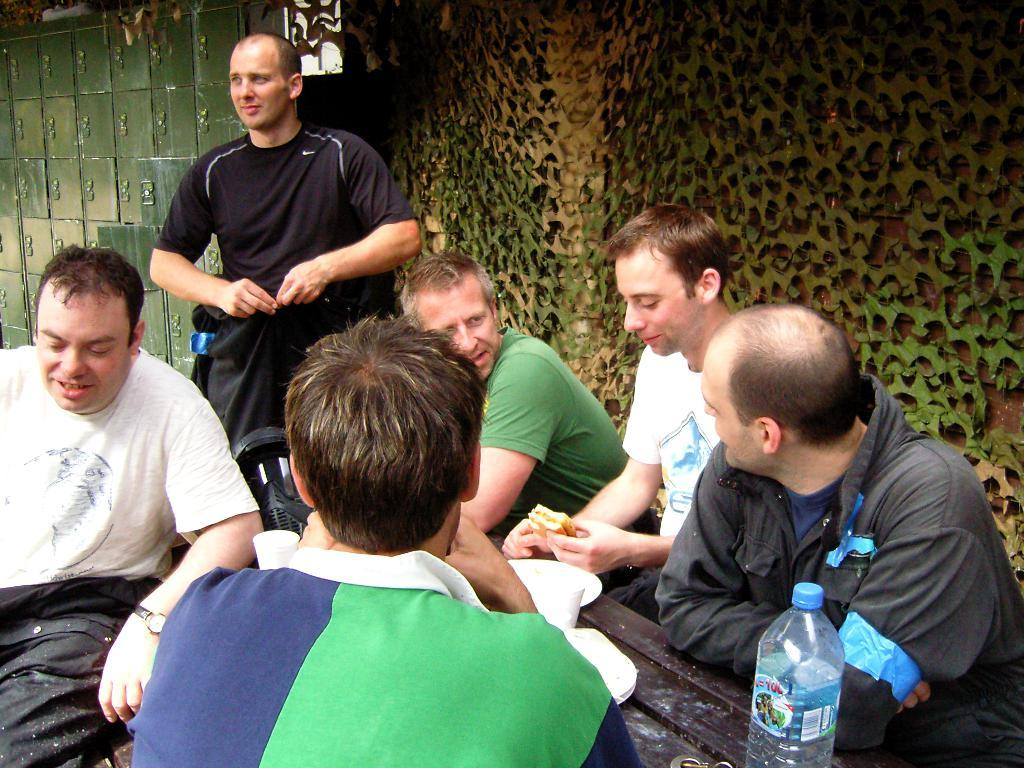What is happening in the image involving the group of persons? There is a group of persons sitting in front of a table. Can you describe the person standing beside the group? There is a person wearing a black shirt standing beside the group. What can be seen in the background of the image? There are lockers in the background of the image. What type of stone is being used as a table in the image? There is no stone table present in the image; the table is not described as being made of stone. Is there a cord visible in the image? There is no mention of a cord in the provided facts, so it cannot be determined if one is present in the image. 